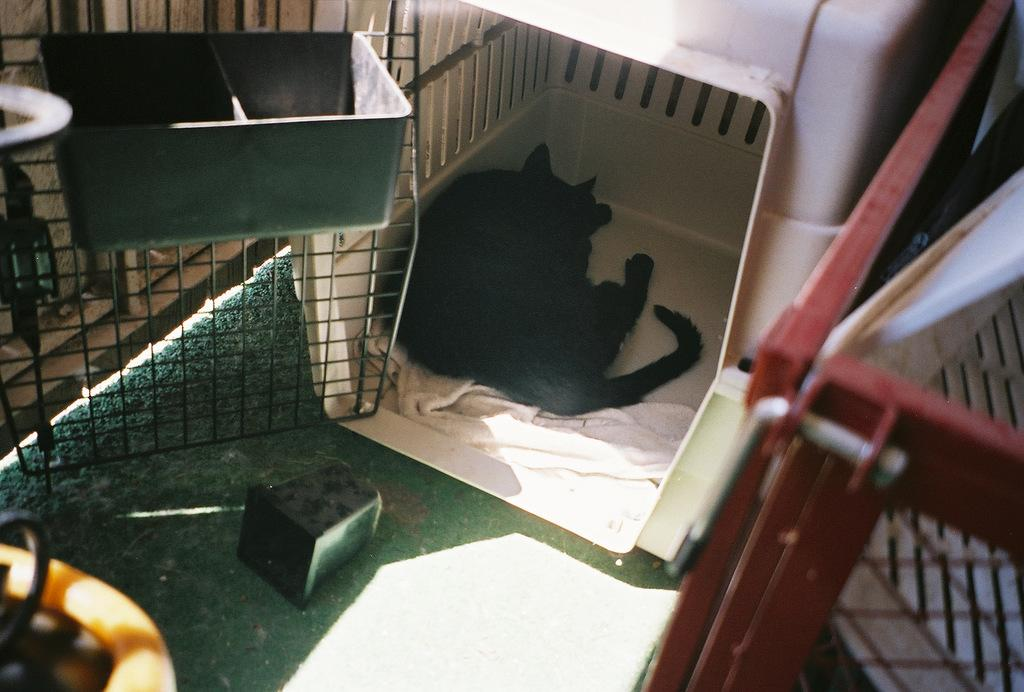What animal can be seen in the image? There is a dog laying on a surface in the image. What is the dog laying on? The towel is visible in the image, and it is likely that the dog is laying on it. Can you describe any other objects in the image? There is a box on a mesh in the image. How many horses are visible on the sidewalk in the image? There are no horses or sidewalks present in the image. What type of dust can be seen on the dog in the image? There is no dust visible on the dog in the image. 